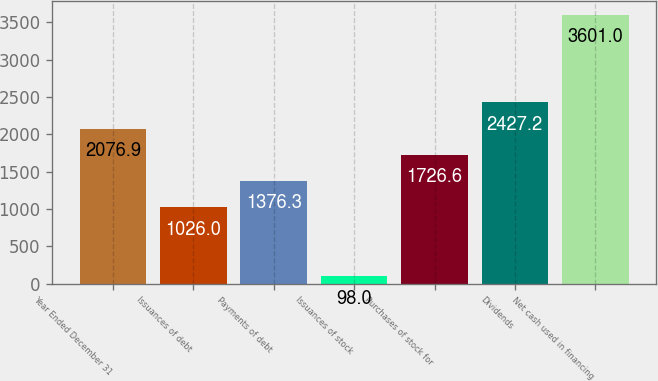Convert chart to OTSL. <chart><loc_0><loc_0><loc_500><loc_500><bar_chart><fcel>Year Ended December 31<fcel>Issuances of debt<fcel>Payments of debt<fcel>Issuances of stock<fcel>Purchases of stock for<fcel>Dividends<fcel>Net cash used in financing<nl><fcel>2076.9<fcel>1026<fcel>1376.3<fcel>98<fcel>1726.6<fcel>2427.2<fcel>3601<nl></chart> 